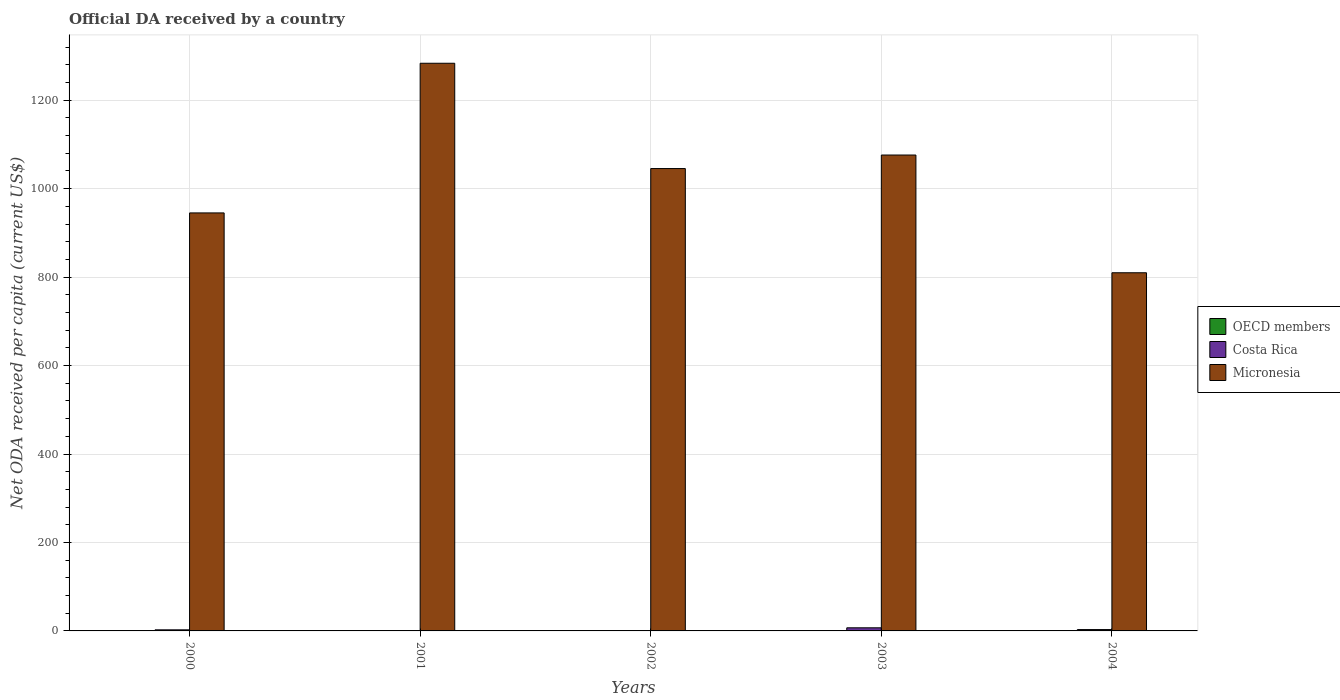How many different coloured bars are there?
Your answer should be compact. 3. How many groups of bars are there?
Provide a short and direct response. 5. Are the number of bars on each tick of the X-axis equal?
Your answer should be compact. No. How many bars are there on the 1st tick from the left?
Offer a terse response. 3. How many bars are there on the 5th tick from the right?
Ensure brevity in your answer.  3. What is the label of the 5th group of bars from the left?
Ensure brevity in your answer.  2004. What is the ODA received in in OECD members in 2000?
Your response must be concise. 0.33. Across all years, what is the maximum ODA received in in Costa Rica?
Offer a terse response. 7.04. Across all years, what is the minimum ODA received in in OECD members?
Make the answer very short. 0.32. What is the total ODA received in in OECD members in the graph?
Provide a short and direct response. 1.79. What is the difference between the ODA received in in Micronesia in 2001 and that in 2004?
Ensure brevity in your answer.  473.72. What is the difference between the ODA received in in Micronesia in 2003 and the ODA received in in OECD members in 2004?
Give a very brief answer. 1075.68. What is the average ODA received in in OECD members per year?
Ensure brevity in your answer.  0.36. In the year 2003, what is the difference between the ODA received in in OECD members and ODA received in in Micronesia?
Offer a very short reply. -1075.74. What is the ratio of the ODA received in in OECD members in 2001 to that in 2002?
Provide a short and direct response. 1.01. Is the ODA received in in Costa Rica in 2000 less than that in 2001?
Your answer should be very brief. No. What is the difference between the highest and the second highest ODA received in in OECD members?
Ensure brevity in your answer.  0. What is the difference between the highest and the lowest ODA received in in OECD members?
Make the answer very short. 0.07. Is the sum of the ODA received in in OECD members in 2003 and 2004 greater than the maximum ODA received in in Costa Rica across all years?
Provide a short and direct response. No. Are all the bars in the graph horizontal?
Ensure brevity in your answer.  No. What is the difference between two consecutive major ticks on the Y-axis?
Offer a terse response. 200. Where does the legend appear in the graph?
Offer a very short reply. Center right. How are the legend labels stacked?
Ensure brevity in your answer.  Vertical. What is the title of the graph?
Offer a very short reply. Official DA received by a country. Does "Bosnia and Herzegovina" appear as one of the legend labels in the graph?
Offer a very short reply. No. What is the label or title of the Y-axis?
Offer a very short reply. Net ODA received per capita (current US$). What is the Net ODA received per capita (current US$) in OECD members in 2000?
Provide a short and direct response. 0.33. What is the Net ODA received per capita (current US$) in Costa Rica in 2000?
Offer a terse response. 2.45. What is the Net ODA received per capita (current US$) of Micronesia in 2000?
Provide a succinct answer. 945.17. What is the Net ODA received per capita (current US$) of OECD members in 2001?
Your answer should be compact. 0.39. What is the Net ODA received per capita (current US$) in Costa Rica in 2001?
Make the answer very short. 0.09. What is the Net ODA received per capita (current US$) in Micronesia in 2001?
Your answer should be compact. 1283.57. What is the Net ODA received per capita (current US$) in OECD members in 2002?
Offer a terse response. 0.38. What is the Net ODA received per capita (current US$) of Costa Rica in 2002?
Provide a succinct answer. 0. What is the Net ODA received per capita (current US$) in Micronesia in 2002?
Provide a short and direct response. 1045.49. What is the Net ODA received per capita (current US$) of OECD members in 2003?
Make the answer very short. 0.32. What is the Net ODA received per capita (current US$) of Costa Rica in 2003?
Offer a terse response. 7.04. What is the Net ODA received per capita (current US$) in Micronesia in 2003?
Offer a terse response. 1076.06. What is the Net ODA received per capita (current US$) in OECD members in 2004?
Provide a short and direct response. 0.38. What is the Net ODA received per capita (current US$) in Costa Rica in 2004?
Provide a short and direct response. 3.05. What is the Net ODA received per capita (current US$) in Micronesia in 2004?
Offer a very short reply. 809.85. Across all years, what is the maximum Net ODA received per capita (current US$) in OECD members?
Give a very brief answer. 0.39. Across all years, what is the maximum Net ODA received per capita (current US$) of Costa Rica?
Make the answer very short. 7.04. Across all years, what is the maximum Net ODA received per capita (current US$) of Micronesia?
Offer a terse response. 1283.57. Across all years, what is the minimum Net ODA received per capita (current US$) of OECD members?
Your answer should be very brief. 0.32. Across all years, what is the minimum Net ODA received per capita (current US$) in Micronesia?
Your response must be concise. 809.85. What is the total Net ODA received per capita (current US$) in OECD members in the graph?
Keep it short and to the point. 1.79. What is the total Net ODA received per capita (current US$) of Costa Rica in the graph?
Ensure brevity in your answer.  12.63. What is the total Net ODA received per capita (current US$) of Micronesia in the graph?
Offer a very short reply. 5160.14. What is the difference between the Net ODA received per capita (current US$) in OECD members in 2000 and that in 2001?
Offer a terse response. -0.06. What is the difference between the Net ODA received per capita (current US$) of Costa Rica in 2000 and that in 2001?
Make the answer very short. 2.36. What is the difference between the Net ODA received per capita (current US$) in Micronesia in 2000 and that in 2001?
Provide a short and direct response. -338.39. What is the difference between the Net ODA received per capita (current US$) in OECD members in 2000 and that in 2002?
Offer a very short reply. -0.06. What is the difference between the Net ODA received per capita (current US$) in Micronesia in 2000 and that in 2002?
Your answer should be compact. -100.32. What is the difference between the Net ODA received per capita (current US$) of OECD members in 2000 and that in 2003?
Give a very brief answer. 0.01. What is the difference between the Net ODA received per capita (current US$) of Costa Rica in 2000 and that in 2003?
Provide a short and direct response. -4.59. What is the difference between the Net ODA received per capita (current US$) of Micronesia in 2000 and that in 2003?
Keep it short and to the point. -130.88. What is the difference between the Net ODA received per capita (current US$) in OECD members in 2000 and that in 2004?
Give a very brief answer. -0.05. What is the difference between the Net ODA received per capita (current US$) of Costa Rica in 2000 and that in 2004?
Ensure brevity in your answer.  -0.6. What is the difference between the Net ODA received per capita (current US$) in Micronesia in 2000 and that in 2004?
Give a very brief answer. 135.32. What is the difference between the Net ODA received per capita (current US$) in OECD members in 2001 and that in 2002?
Offer a very short reply. 0. What is the difference between the Net ODA received per capita (current US$) of Micronesia in 2001 and that in 2002?
Your answer should be compact. 238.07. What is the difference between the Net ODA received per capita (current US$) of OECD members in 2001 and that in 2003?
Offer a very short reply. 0.07. What is the difference between the Net ODA received per capita (current US$) of Costa Rica in 2001 and that in 2003?
Ensure brevity in your answer.  -6.94. What is the difference between the Net ODA received per capita (current US$) of Micronesia in 2001 and that in 2003?
Keep it short and to the point. 207.51. What is the difference between the Net ODA received per capita (current US$) in OECD members in 2001 and that in 2004?
Offer a very short reply. 0.01. What is the difference between the Net ODA received per capita (current US$) of Costa Rica in 2001 and that in 2004?
Offer a very short reply. -2.96. What is the difference between the Net ODA received per capita (current US$) of Micronesia in 2001 and that in 2004?
Give a very brief answer. 473.72. What is the difference between the Net ODA received per capita (current US$) of OECD members in 2002 and that in 2003?
Provide a succinct answer. 0.07. What is the difference between the Net ODA received per capita (current US$) in Micronesia in 2002 and that in 2003?
Your answer should be compact. -30.56. What is the difference between the Net ODA received per capita (current US$) of OECD members in 2002 and that in 2004?
Your response must be concise. 0.01. What is the difference between the Net ODA received per capita (current US$) in Micronesia in 2002 and that in 2004?
Provide a succinct answer. 235.64. What is the difference between the Net ODA received per capita (current US$) of OECD members in 2003 and that in 2004?
Keep it short and to the point. -0.06. What is the difference between the Net ODA received per capita (current US$) of Costa Rica in 2003 and that in 2004?
Ensure brevity in your answer.  3.99. What is the difference between the Net ODA received per capita (current US$) of Micronesia in 2003 and that in 2004?
Keep it short and to the point. 266.2. What is the difference between the Net ODA received per capita (current US$) of OECD members in 2000 and the Net ODA received per capita (current US$) of Costa Rica in 2001?
Keep it short and to the point. 0.24. What is the difference between the Net ODA received per capita (current US$) of OECD members in 2000 and the Net ODA received per capita (current US$) of Micronesia in 2001?
Your response must be concise. -1283.24. What is the difference between the Net ODA received per capita (current US$) in Costa Rica in 2000 and the Net ODA received per capita (current US$) in Micronesia in 2001?
Provide a succinct answer. -1281.12. What is the difference between the Net ODA received per capita (current US$) in OECD members in 2000 and the Net ODA received per capita (current US$) in Micronesia in 2002?
Make the answer very short. -1045.17. What is the difference between the Net ODA received per capita (current US$) of Costa Rica in 2000 and the Net ODA received per capita (current US$) of Micronesia in 2002?
Your answer should be very brief. -1043.04. What is the difference between the Net ODA received per capita (current US$) in OECD members in 2000 and the Net ODA received per capita (current US$) in Costa Rica in 2003?
Your answer should be very brief. -6.71. What is the difference between the Net ODA received per capita (current US$) in OECD members in 2000 and the Net ODA received per capita (current US$) in Micronesia in 2003?
Your answer should be compact. -1075.73. What is the difference between the Net ODA received per capita (current US$) in Costa Rica in 2000 and the Net ODA received per capita (current US$) in Micronesia in 2003?
Your answer should be compact. -1073.61. What is the difference between the Net ODA received per capita (current US$) of OECD members in 2000 and the Net ODA received per capita (current US$) of Costa Rica in 2004?
Your response must be concise. -2.72. What is the difference between the Net ODA received per capita (current US$) in OECD members in 2000 and the Net ODA received per capita (current US$) in Micronesia in 2004?
Give a very brief answer. -809.52. What is the difference between the Net ODA received per capita (current US$) of Costa Rica in 2000 and the Net ODA received per capita (current US$) of Micronesia in 2004?
Your answer should be very brief. -807.4. What is the difference between the Net ODA received per capita (current US$) in OECD members in 2001 and the Net ODA received per capita (current US$) in Micronesia in 2002?
Offer a very short reply. -1045.11. What is the difference between the Net ODA received per capita (current US$) of Costa Rica in 2001 and the Net ODA received per capita (current US$) of Micronesia in 2002?
Provide a succinct answer. -1045.4. What is the difference between the Net ODA received per capita (current US$) in OECD members in 2001 and the Net ODA received per capita (current US$) in Costa Rica in 2003?
Keep it short and to the point. -6.65. What is the difference between the Net ODA received per capita (current US$) in OECD members in 2001 and the Net ODA received per capita (current US$) in Micronesia in 2003?
Ensure brevity in your answer.  -1075.67. What is the difference between the Net ODA received per capita (current US$) in Costa Rica in 2001 and the Net ODA received per capita (current US$) in Micronesia in 2003?
Offer a very short reply. -1075.96. What is the difference between the Net ODA received per capita (current US$) of OECD members in 2001 and the Net ODA received per capita (current US$) of Costa Rica in 2004?
Provide a short and direct response. -2.66. What is the difference between the Net ODA received per capita (current US$) in OECD members in 2001 and the Net ODA received per capita (current US$) in Micronesia in 2004?
Provide a succinct answer. -809.46. What is the difference between the Net ODA received per capita (current US$) of Costa Rica in 2001 and the Net ODA received per capita (current US$) of Micronesia in 2004?
Provide a succinct answer. -809.76. What is the difference between the Net ODA received per capita (current US$) of OECD members in 2002 and the Net ODA received per capita (current US$) of Costa Rica in 2003?
Make the answer very short. -6.65. What is the difference between the Net ODA received per capita (current US$) in OECD members in 2002 and the Net ODA received per capita (current US$) in Micronesia in 2003?
Ensure brevity in your answer.  -1075.67. What is the difference between the Net ODA received per capita (current US$) in OECD members in 2002 and the Net ODA received per capita (current US$) in Costa Rica in 2004?
Your answer should be compact. -2.67. What is the difference between the Net ODA received per capita (current US$) in OECD members in 2002 and the Net ODA received per capita (current US$) in Micronesia in 2004?
Offer a terse response. -809.47. What is the difference between the Net ODA received per capita (current US$) in OECD members in 2003 and the Net ODA received per capita (current US$) in Costa Rica in 2004?
Provide a succinct answer. -2.73. What is the difference between the Net ODA received per capita (current US$) in OECD members in 2003 and the Net ODA received per capita (current US$) in Micronesia in 2004?
Keep it short and to the point. -809.54. What is the difference between the Net ODA received per capita (current US$) in Costa Rica in 2003 and the Net ODA received per capita (current US$) in Micronesia in 2004?
Keep it short and to the point. -802.82. What is the average Net ODA received per capita (current US$) of OECD members per year?
Your answer should be compact. 0.36. What is the average Net ODA received per capita (current US$) of Costa Rica per year?
Provide a succinct answer. 2.53. What is the average Net ODA received per capita (current US$) in Micronesia per year?
Make the answer very short. 1032.03. In the year 2000, what is the difference between the Net ODA received per capita (current US$) of OECD members and Net ODA received per capita (current US$) of Costa Rica?
Your answer should be very brief. -2.12. In the year 2000, what is the difference between the Net ODA received per capita (current US$) of OECD members and Net ODA received per capita (current US$) of Micronesia?
Provide a short and direct response. -944.85. In the year 2000, what is the difference between the Net ODA received per capita (current US$) of Costa Rica and Net ODA received per capita (current US$) of Micronesia?
Ensure brevity in your answer.  -942.72. In the year 2001, what is the difference between the Net ODA received per capita (current US$) in OECD members and Net ODA received per capita (current US$) in Costa Rica?
Give a very brief answer. 0.29. In the year 2001, what is the difference between the Net ODA received per capita (current US$) in OECD members and Net ODA received per capita (current US$) in Micronesia?
Offer a very short reply. -1283.18. In the year 2001, what is the difference between the Net ODA received per capita (current US$) of Costa Rica and Net ODA received per capita (current US$) of Micronesia?
Your response must be concise. -1283.48. In the year 2002, what is the difference between the Net ODA received per capita (current US$) in OECD members and Net ODA received per capita (current US$) in Micronesia?
Provide a short and direct response. -1045.11. In the year 2003, what is the difference between the Net ODA received per capita (current US$) in OECD members and Net ODA received per capita (current US$) in Costa Rica?
Give a very brief answer. -6.72. In the year 2003, what is the difference between the Net ODA received per capita (current US$) of OECD members and Net ODA received per capita (current US$) of Micronesia?
Ensure brevity in your answer.  -1075.74. In the year 2003, what is the difference between the Net ODA received per capita (current US$) of Costa Rica and Net ODA received per capita (current US$) of Micronesia?
Offer a terse response. -1069.02. In the year 2004, what is the difference between the Net ODA received per capita (current US$) of OECD members and Net ODA received per capita (current US$) of Costa Rica?
Provide a short and direct response. -2.67. In the year 2004, what is the difference between the Net ODA received per capita (current US$) in OECD members and Net ODA received per capita (current US$) in Micronesia?
Your response must be concise. -809.48. In the year 2004, what is the difference between the Net ODA received per capita (current US$) in Costa Rica and Net ODA received per capita (current US$) in Micronesia?
Offer a very short reply. -806.8. What is the ratio of the Net ODA received per capita (current US$) in OECD members in 2000 to that in 2001?
Your answer should be very brief. 0.85. What is the ratio of the Net ODA received per capita (current US$) in Costa Rica in 2000 to that in 2001?
Provide a short and direct response. 26.47. What is the ratio of the Net ODA received per capita (current US$) of Micronesia in 2000 to that in 2001?
Ensure brevity in your answer.  0.74. What is the ratio of the Net ODA received per capita (current US$) in OECD members in 2000 to that in 2002?
Your answer should be very brief. 0.85. What is the ratio of the Net ODA received per capita (current US$) in Micronesia in 2000 to that in 2002?
Keep it short and to the point. 0.9. What is the ratio of the Net ODA received per capita (current US$) in OECD members in 2000 to that in 2003?
Give a very brief answer. 1.04. What is the ratio of the Net ODA received per capita (current US$) of Costa Rica in 2000 to that in 2003?
Your response must be concise. 0.35. What is the ratio of the Net ODA received per capita (current US$) of Micronesia in 2000 to that in 2003?
Offer a terse response. 0.88. What is the ratio of the Net ODA received per capita (current US$) of OECD members in 2000 to that in 2004?
Offer a terse response. 0.87. What is the ratio of the Net ODA received per capita (current US$) in Costa Rica in 2000 to that in 2004?
Your answer should be very brief. 0.8. What is the ratio of the Net ODA received per capita (current US$) of Micronesia in 2000 to that in 2004?
Offer a terse response. 1.17. What is the ratio of the Net ODA received per capita (current US$) in OECD members in 2001 to that in 2002?
Provide a short and direct response. 1.01. What is the ratio of the Net ODA received per capita (current US$) in Micronesia in 2001 to that in 2002?
Offer a very short reply. 1.23. What is the ratio of the Net ODA received per capita (current US$) in OECD members in 2001 to that in 2003?
Ensure brevity in your answer.  1.22. What is the ratio of the Net ODA received per capita (current US$) of Costa Rica in 2001 to that in 2003?
Provide a short and direct response. 0.01. What is the ratio of the Net ODA received per capita (current US$) of Micronesia in 2001 to that in 2003?
Your response must be concise. 1.19. What is the ratio of the Net ODA received per capita (current US$) of OECD members in 2001 to that in 2004?
Make the answer very short. 1.03. What is the ratio of the Net ODA received per capita (current US$) of Costa Rica in 2001 to that in 2004?
Offer a very short reply. 0.03. What is the ratio of the Net ODA received per capita (current US$) in Micronesia in 2001 to that in 2004?
Give a very brief answer. 1.58. What is the ratio of the Net ODA received per capita (current US$) in OECD members in 2002 to that in 2003?
Provide a succinct answer. 1.21. What is the ratio of the Net ODA received per capita (current US$) in Micronesia in 2002 to that in 2003?
Ensure brevity in your answer.  0.97. What is the ratio of the Net ODA received per capita (current US$) in OECD members in 2002 to that in 2004?
Your response must be concise. 1.02. What is the ratio of the Net ODA received per capita (current US$) of Micronesia in 2002 to that in 2004?
Provide a succinct answer. 1.29. What is the ratio of the Net ODA received per capita (current US$) of OECD members in 2003 to that in 2004?
Give a very brief answer. 0.84. What is the ratio of the Net ODA received per capita (current US$) in Costa Rica in 2003 to that in 2004?
Your response must be concise. 2.31. What is the ratio of the Net ODA received per capita (current US$) in Micronesia in 2003 to that in 2004?
Give a very brief answer. 1.33. What is the difference between the highest and the second highest Net ODA received per capita (current US$) in OECD members?
Make the answer very short. 0. What is the difference between the highest and the second highest Net ODA received per capita (current US$) of Costa Rica?
Provide a short and direct response. 3.99. What is the difference between the highest and the second highest Net ODA received per capita (current US$) in Micronesia?
Provide a succinct answer. 207.51. What is the difference between the highest and the lowest Net ODA received per capita (current US$) of OECD members?
Your answer should be very brief. 0.07. What is the difference between the highest and the lowest Net ODA received per capita (current US$) in Costa Rica?
Your answer should be very brief. 7.04. What is the difference between the highest and the lowest Net ODA received per capita (current US$) in Micronesia?
Your response must be concise. 473.72. 